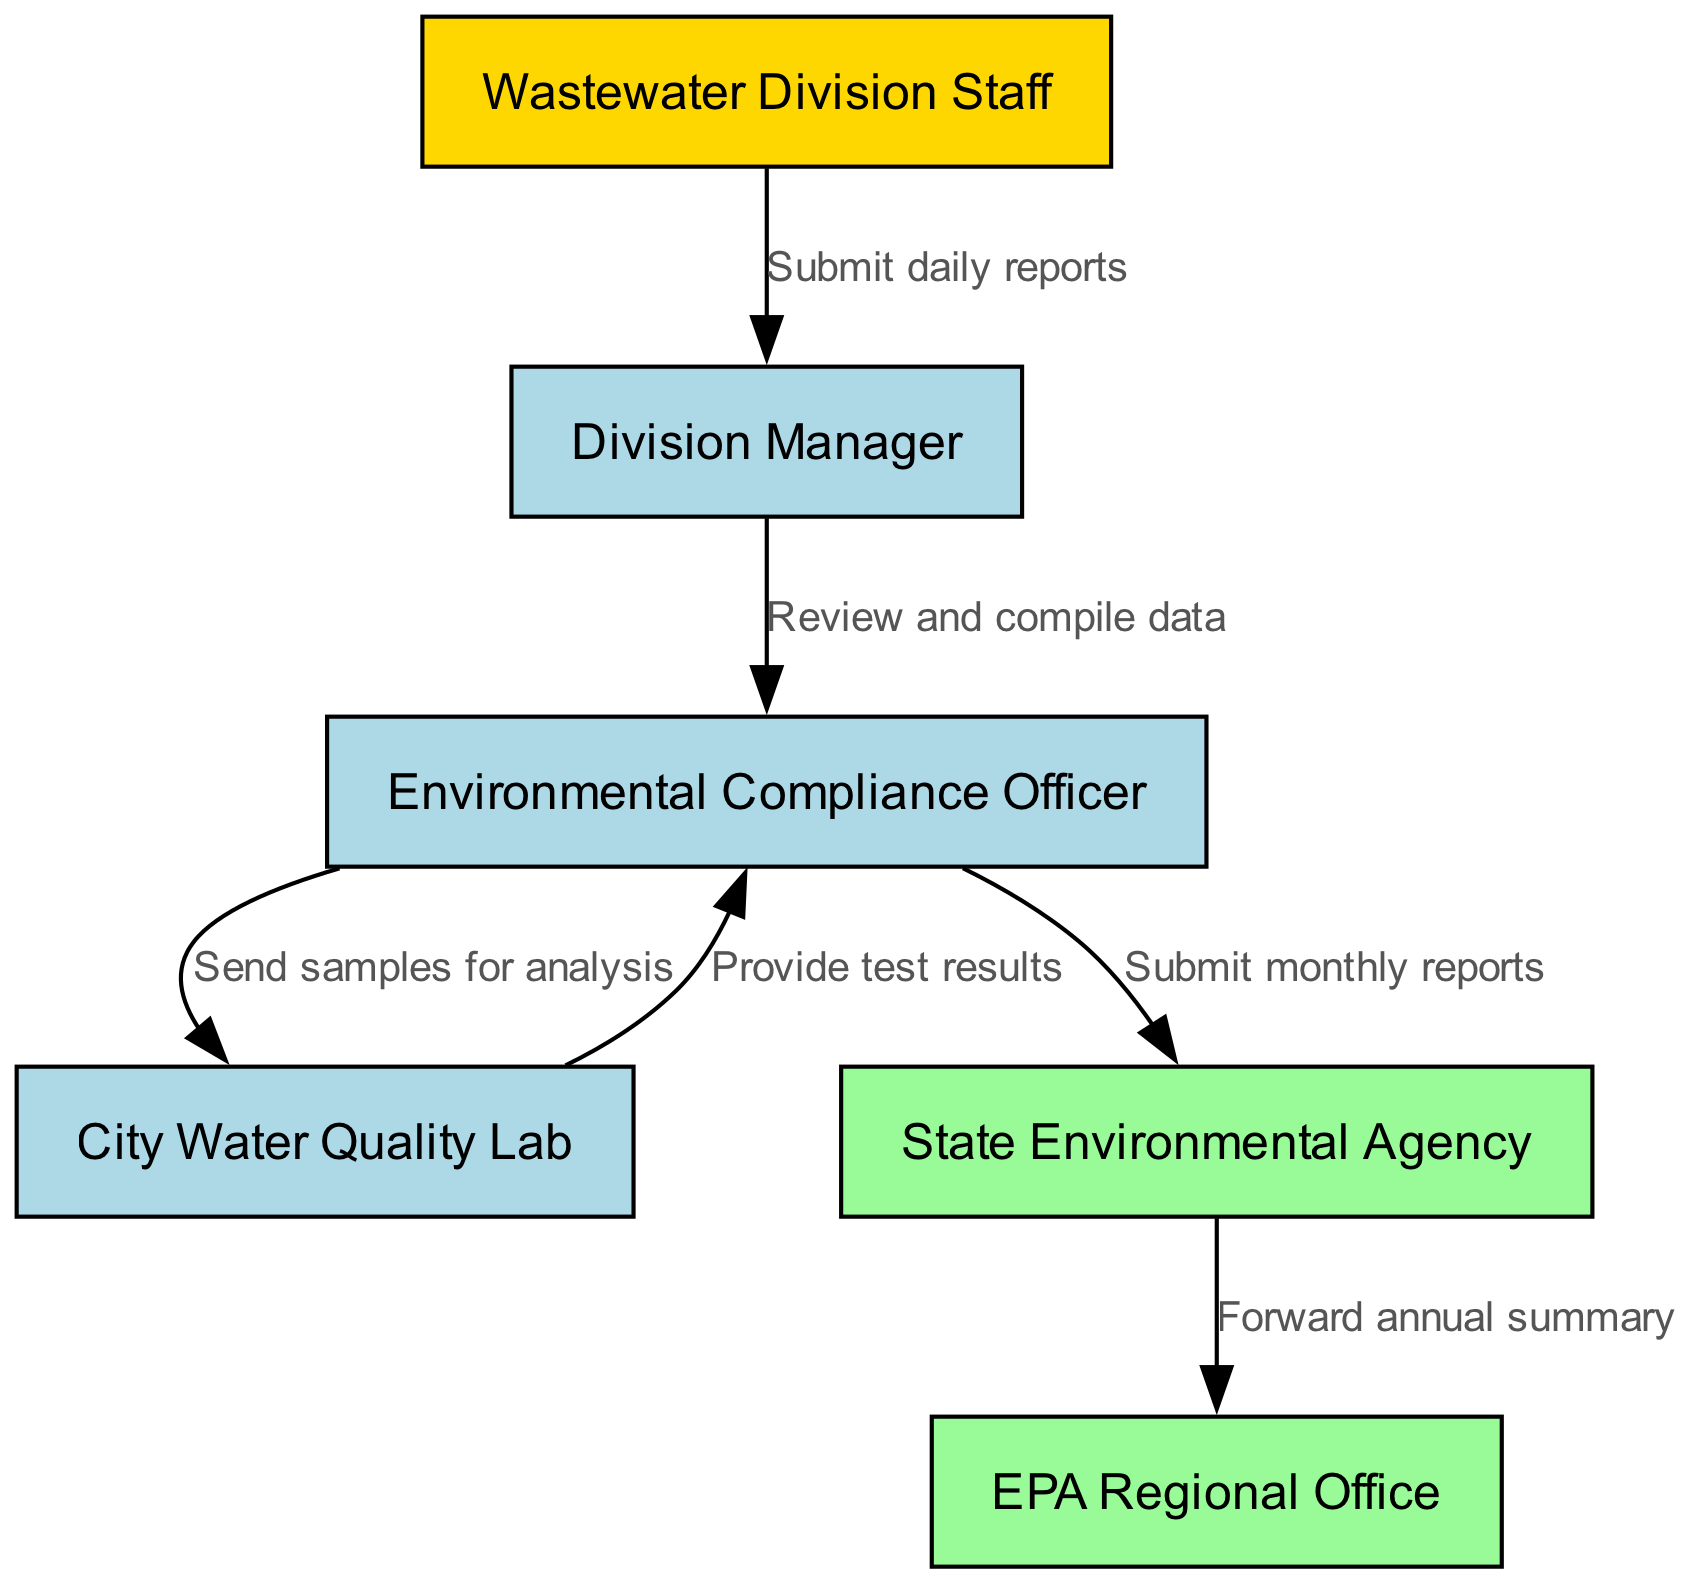What is the first node in the reporting chain? The first node mentioned is the "Wastewater Division Staff," which is where the reporting chain begins.
Answer: Wastewater Division Staff How many nodes are in the diagram? The diagram consists of six distinct nodes: "Wastewater Division Staff," "Division Manager," "Environmental Compliance Officer," "City Water Quality Lab," "State Environmental Agency," and "EPA Regional Office."
Answer: Six What edge connects the Division Manager to the Environmental Compliance Officer? The edge connecting these two nodes is labeled "Review and compile data," indicating the relationship between the Division Manager and the Environmental Compliance Officer.
Answer: Review and compile data Which node does the Environmental Compliance Officer submit monthly reports to? The Environmental Compliance Officer submits monthly reports to the "State Environmental Agency," as indicated by the arrows and labels on the diagram.
Answer: State Environmental Agency What is the last step before submission to the EPA Regional Office? The last step is the "State Environmental Agency" forwarding the annual summary to the "EPA Regional Office," as shown in the final arrow in the reporting chain.
Answer: Forward annual summary Which department sends samples for analysis? The "Environmental Compliance Officer" sends samples for analysis to the "City Water Quality Lab," as indicated by the directed edge in the diagram.
Answer: City Water Quality Lab What is the relationship between the City Water Quality Lab and the Environmental Compliance Officer? The relationship is defined by the edge labeled "Provide test results," indicating that the lab provides results to the officer after analysis.
Answer: Provide test results How many edges are depicted in the reporting chain? There are a total of six edges illustrated in the diagram, representing the various steps and communications among the nodes.
Answer: Six What color highlights the Wastewater Division Staff in the diagram? The color used to highlight the "Wastewater Division Staff" is gold, distinguishing it from other nodes in the diagram.
Answer: Gold Which two nodes are colored differently as external agencies? The two nodes colored differently as external agencies are the "State Environmental Agency" and the "EPA Regional Office," indicating their role as external entities in the reporting chain.
Answer: State Environmental Agency, EPA Regional Office 